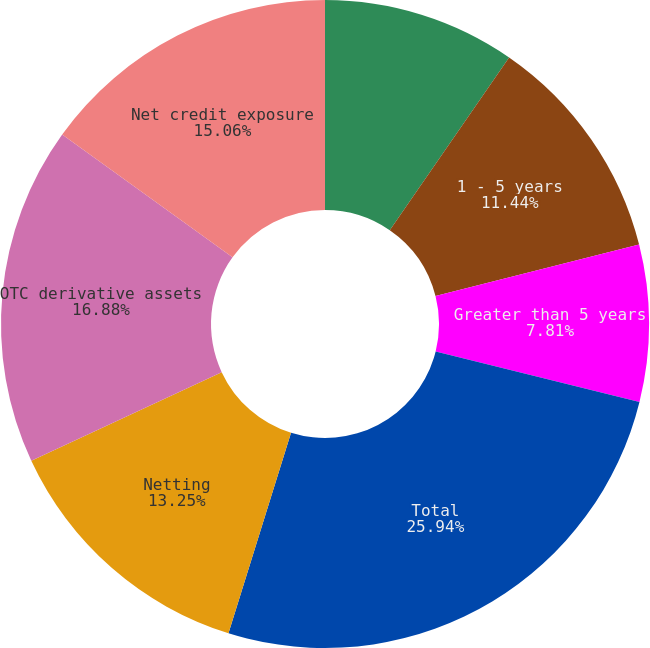<chart> <loc_0><loc_0><loc_500><loc_500><pie_chart><fcel>Less than 1 year<fcel>1 - 5 years<fcel>Greater than 5 years<fcel>Total<fcel>Netting<fcel>OTC derivative assets<fcel>Net credit exposure<nl><fcel>9.62%<fcel>11.44%<fcel>7.81%<fcel>25.95%<fcel>13.25%<fcel>16.88%<fcel>15.06%<nl></chart> 